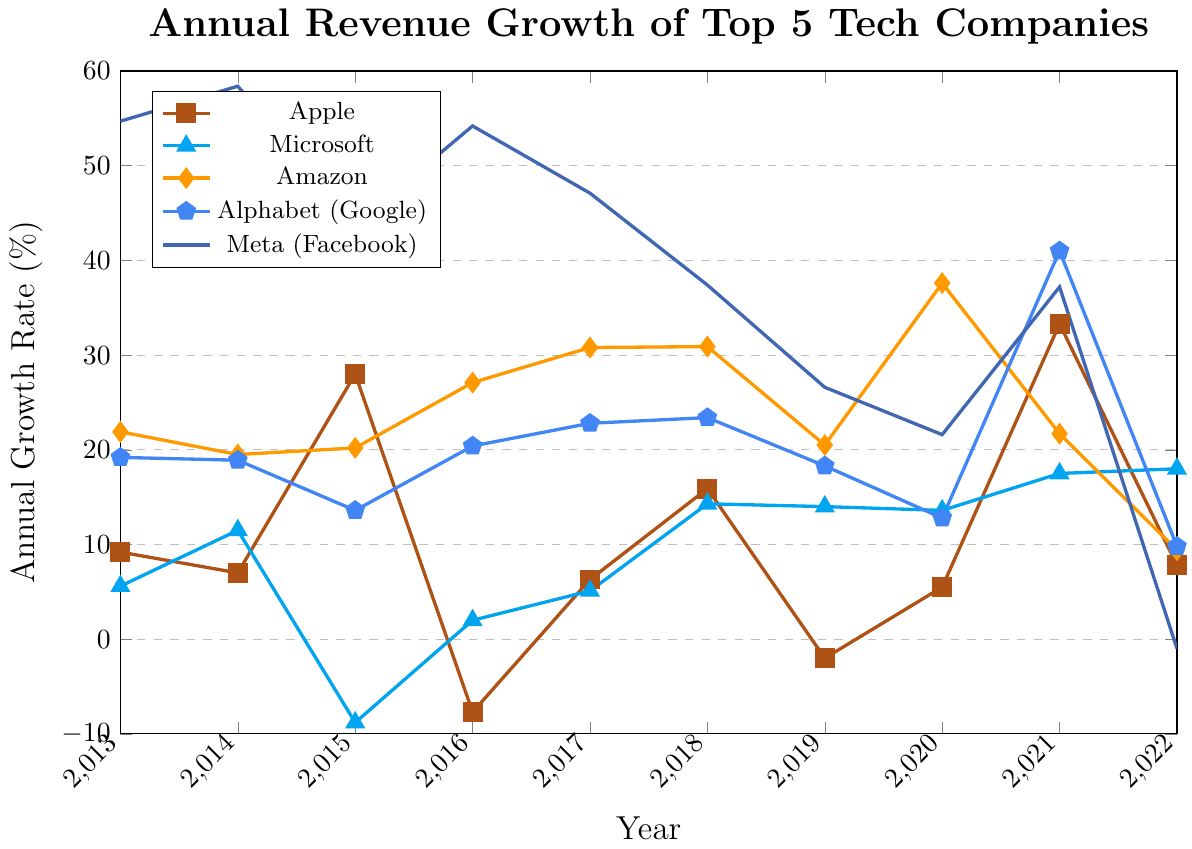What was Apple's highest annual revenue growth rate over the decade? The highest annual revenue growth rate for Apple can be observed by looking for the peak point in Apple's line in the plot, which corresponds to 2015 with a value of 28.0%.
Answer: 28.0% Which company had the steepest decline in annual revenue growth in any given year? The steepest decline can be seen by identifying the largest drop between two consecutive years. Meta had the steepest decline from 2021 (37.2%) to 2022 (-1.0%), a drop of 38.2 percentage points.
Answer: Meta Compare the annual revenue growth of Amazon and Microsoft in 2020. Which company had a higher growth rate? By looking at the 2020 data points for Amazon and Microsoft, Amazon had a growth rate of 37.6% and Microsoft had 13.6%. Thus, Amazon had a higher growth rate.
Answer: Amazon Calculate the average annual revenue growth rate for Apple from 2013 to 2022. Summing up Apple's growth rates: 9.2 + 7.0 + 28.0 + (-7.7) + 6.3 + 15.9 + (-2.0) + 5.5 + 33.3 + 7.8 = 103.3%. Then dividing by the number of years (10), the average annual growth rate is 103.3 / 10 = 10.33%.
Answer: 10.33% What was the revenue growth trend for Meta from 2013 to 2022? Observing Meta's line in the plot, it starts high in 2013 and fluctuates before sharply dropping in 2022. The general trend shows a decline over the decade, especially significant in the final year.
Answer: Declining Which company maintained a relatively stable growth rate over the years? Microsoft’s growth rate line shows relatively smaller fluctuations compared to the other companies, indicating a more stable growth rate over the years.
Answer: Microsoft How did Alphabet’s revenue growth in 2021 compare to its growth in 2020? In 2020, Alphabet’s growth rate was 12.8%, and in 2021, it jumped to 41.0%. The comparison shows a significant increase in the growth rate in 2021.
Answer: Increased significantly Between Amazon and Meta, which company had the higher growth rate in both 2016 and 2017? In 2016, Amazon had a growth rate of 27.1% and Meta had 54.2%. In 2017, Amazon had 30.8% and Meta had 47.1%. Meta had higher growth rates in both 2016 and 2017.
Answer: Meta Among the five companies, which one had negative growth rates in any of the years within the decade? By analyzing the lines, Apple had negative growth rates in 2016 and 2019; Microsoft in 2015; and Meta in 2022. Thus, Apple, Microsoft, and Meta had negative growth rates in some years.
Answer: Apple, Microsoft, Meta 